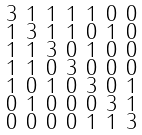<formula> <loc_0><loc_0><loc_500><loc_500>\begin{smallmatrix} 3 & 1 & 1 & 1 & 1 & 0 & 0 \\ 1 & 3 & 1 & 1 & 0 & 1 & 0 \\ 1 & 1 & 3 & 0 & 1 & 0 & 0 \\ 1 & 1 & 0 & 3 & 0 & 0 & 0 \\ 1 & 0 & 1 & 0 & 3 & 0 & 1 \\ 0 & 1 & 0 & 0 & 0 & 3 & 1 \\ 0 & 0 & 0 & 0 & 1 & 1 & 3 \end{smallmatrix}</formula> 